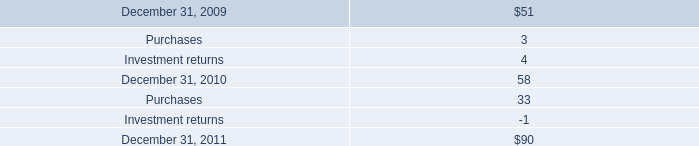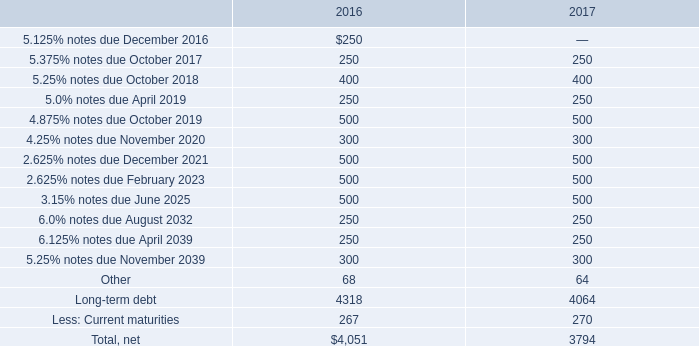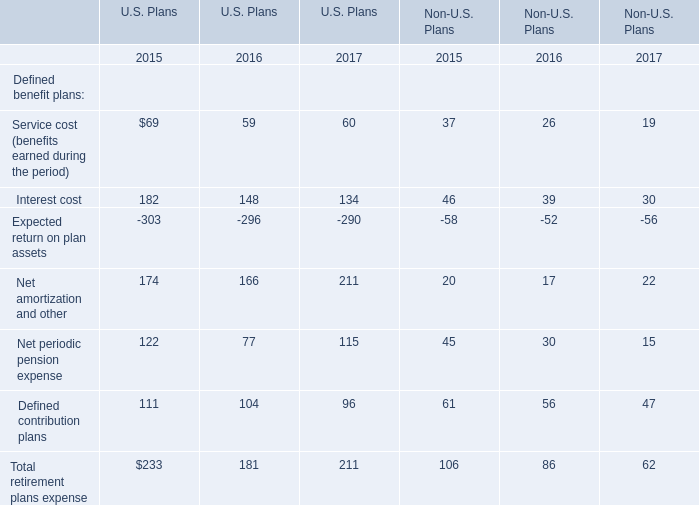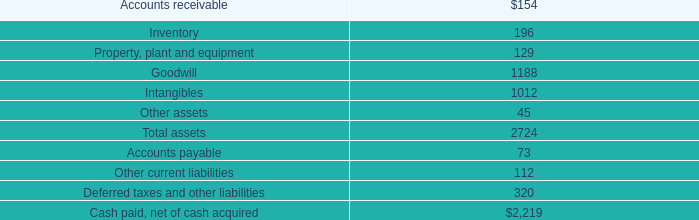What is the average increasing rate of Interest cost in U.S. Plans between 2016 and 2017? 
Computations: ((((148 - 182) / 182) + ((134 - 148) / 148)) / 2)
Answer: -0.1407. 